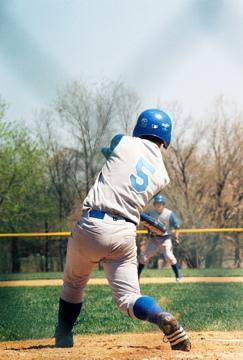How many stripes are on the boy's shoe?
Give a very brief answer. 3. How many orange cups are on the table?
Give a very brief answer. 0. 